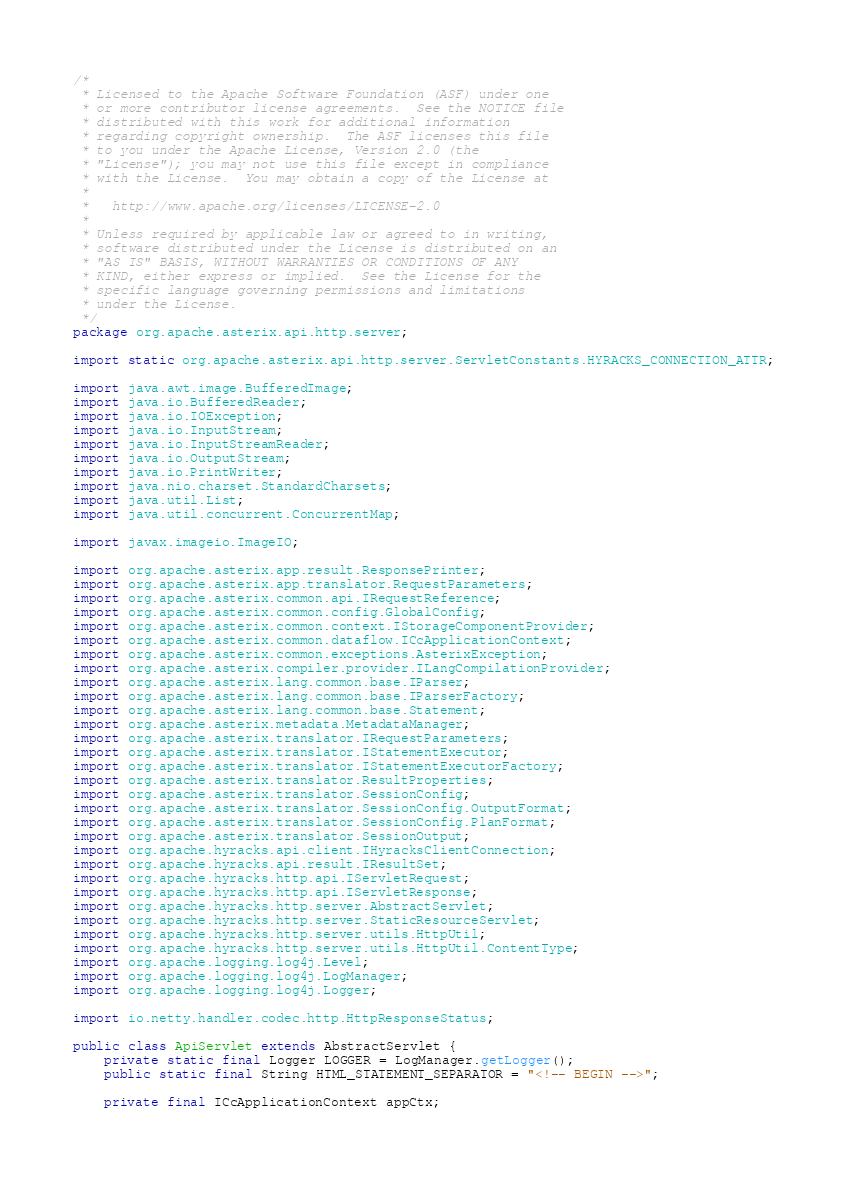<code> <loc_0><loc_0><loc_500><loc_500><_Java_>/*
 * Licensed to the Apache Software Foundation (ASF) under one
 * or more contributor license agreements.  See the NOTICE file
 * distributed with this work for additional information
 * regarding copyright ownership.  The ASF licenses this file
 * to you under the Apache License, Version 2.0 (the
 * "License"); you may not use this file except in compliance
 * with the License.  You may obtain a copy of the License at
 *
 *   http://www.apache.org/licenses/LICENSE-2.0
 *
 * Unless required by applicable law or agreed to in writing,
 * software distributed under the License is distributed on an
 * "AS IS" BASIS, WITHOUT WARRANTIES OR CONDITIONS OF ANY
 * KIND, either express or implied.  See the License for the
 * specific language governing permissions and limitations
 * under the License.
 */
package org.apache.asterix.api.http.server;

import static org.apache.asterix.api.http.server.ServletConstants.HYRACKS_CONNECTION_ATTR;

import java.awt.image.BufferedImage;
import java.io.BufferedReader;
import java.io.IOException;
import java.io.InputStream;
import java.io.InputStreamReader;
import java.io.OutputStream;
import java.io.PrintWriter;
import java.nio.charset.StandardCharsets;
import java.util.List;
import java.util.concurrent.ConcurrentMap;

import javax.imageio.ImageIO;

import org.apache.asterix.app.result.ResponsePrinter;
import org.apache.asterix.app.translator.RequestParameters;
import org.apache.asterix.common.api.IRequestReference;
import org.apache.asterix.common.config.GlobalConfig;
import org.apache.asterix.common.context.IStorageComponentProvider;
import org.apache.asterix.common.dataflow.ICcApplicationContext;
import org.apache.asterix.common.exceptions.AsterixException;
import org.apache.asterix.compiler.provider.ILangCompilationProvider;
import org.apache.asterix.lang.common.base.IParser;
import org.apache.asterix.lang.common.base.IParserFactory;
import org.apache.asterix.lang.common.base.Statement;
import org.apache.asterix.metadata.MetadataManager;
import org.apache.asterix.translator.IRequestParameters;
import org.apache.asterix.translator.IStatementExecutor;
import org.apache.asterix.translator.IStatementExecutorFactory;
import org.apache.asterix.translator.ResultProperties;
import org.apache.asterix.translator.SessionConfig;
import org.apache.asterix.translator.SessionConfig.OutputFormat;
import org.apache.asterix.translator.SessionConfig.PlanFormat;
import org.apache.asterix.translator.SessionOutput;
import org.apache.hyracks.api.client.IHyracksClientConnection;
import org.apache.hyracks.api.result.IResultSet;
import org.apache.hyracks.http.api.IServletRequest;
import org.apache.hyracks.http.api.IServletResponse;
import org.apache.hyracks.http.server.AbstractServlet;
import org.apache.hyracks.http.server.StaticResourceServlet;
import org.apache.hyracks.http.server.utils.HttpUtil;
import org.apache.hyracks.http.server.utils.HttpUtil.ContentType;
import org.apache.logging.log4j.Level;
import org.apache.logging.log4j.LogManager;
import org.apache.logging.log4j.Logger;

import io.netty.handler.codec.http.HttpResponseStatus;

public class ApiServlet extends AbstractServlet {
    private static final Logger LOGGER = LogManager.getLogger();
    public static final String HTML_STATEMENT_SEPARATOR = "<!-- BEGIN -->";

    private final ICcApplicationContext appCtx;</code> 